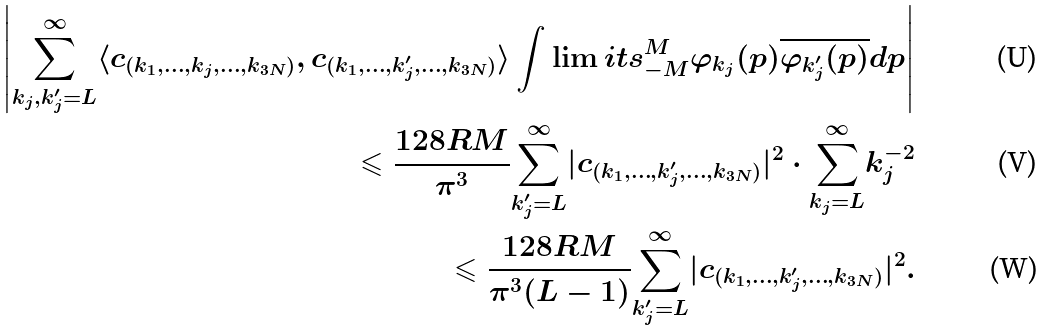Convert formula to latex. <formula><loc_0><loc_0><loc_500><loc_500>\left | \underset { k _ { j } , k _ { j } ^ { \prime } = L } { \overset { \infty } { \sum } } \langle c _ { ( k _ { 1 } , \dots , k _ { j } , \dots , k _ { 3 N } ) } , c _ { ( k _ { 1 } , \dots , k _ { j } ^ { \prime } , \dots , k _ { 3 N } ) } \rangle \int \lim i t s _ { - M } ^ { M } \varphi _ { k _ { j } } ( p ) \overline { \varphi _ { k _ { j } ^ { \prime } } ( p ) } d p \right | \\ \leqslant \frac { 1 2 8 R M } { \pi ^ { 3 } } \underset { k _ { j } ^ { \prime } = L } { \overset { \infty } { \sum } } | c _ { ( k _ { 1 } , \dots , k _ { j } ^ { \prime } , \dots , k _ { 3 N } ) } | ^ { 2 } \cdot \underset { k _ { j } = L } { \overset { \infty } { \sum } } k _ { j } ^ { - 2 } \\ \leqslant \frac { 1 2 8 R M } { \pi ^ { 3 } ( L - 1 ) } \underset { k _ { j } ^ { \prime } = L } { \overset { \infty } { \sum } } | c _ { ( k _ { 1 } , \dots , k _ { j } ^ { \prime } , \dots , k _ { 3 N } ) } | ^ { 2 } .</formula> 